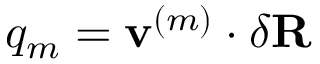<formula> <loc_0><loc_0><loc_500><loc_500>q _ { m } = v ^ { ( m ) } \cdot \delta R</formula> 